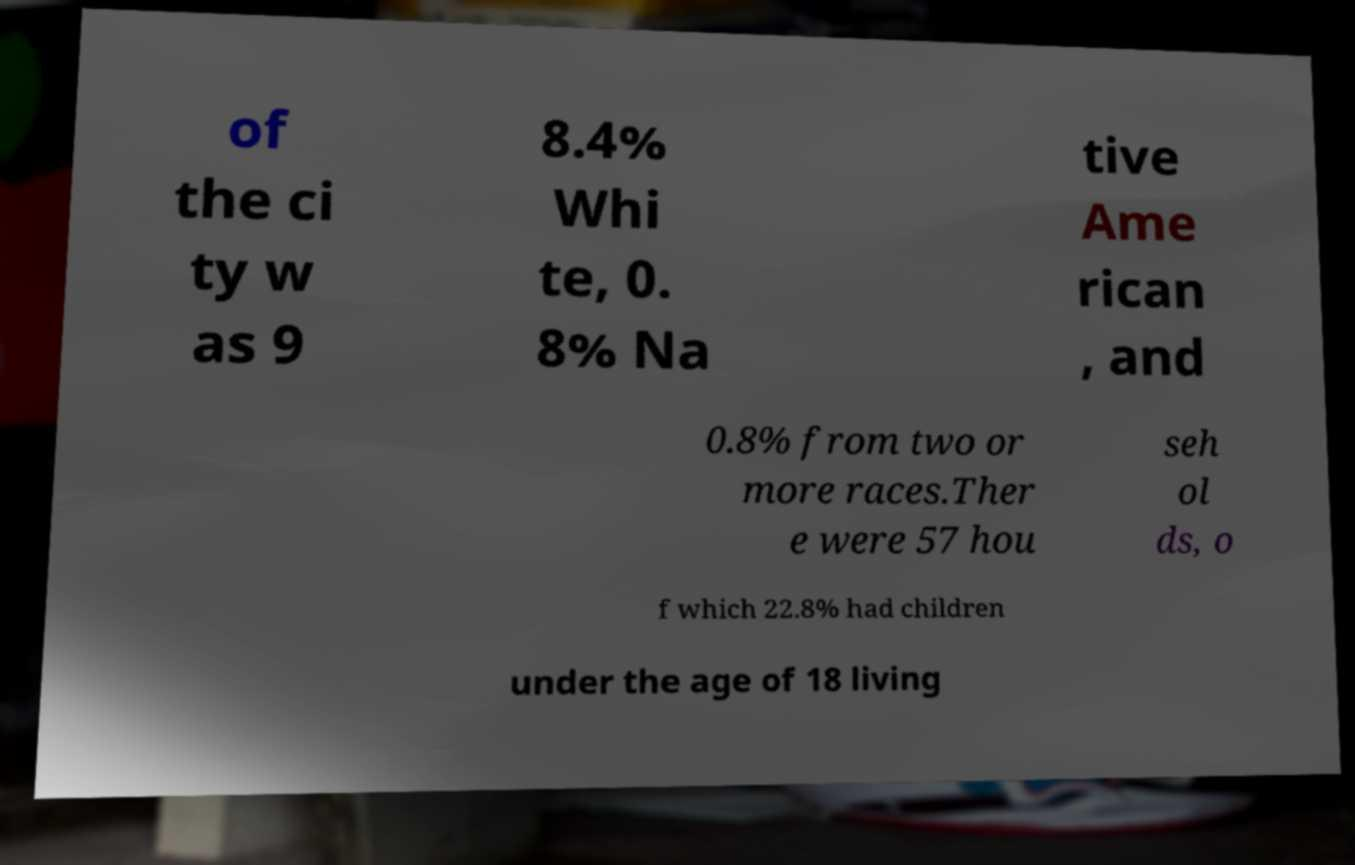What messages or text are displayed in this image? I need them in a readable, typed format. of the ci ty w as 9 8.4% Whi te, 0. 8% Na tive Ame rican , and 0.8% from two or more races.Ther e were 57 hou seh ol ds, o f which 22.8% had children under the age of 18 living 